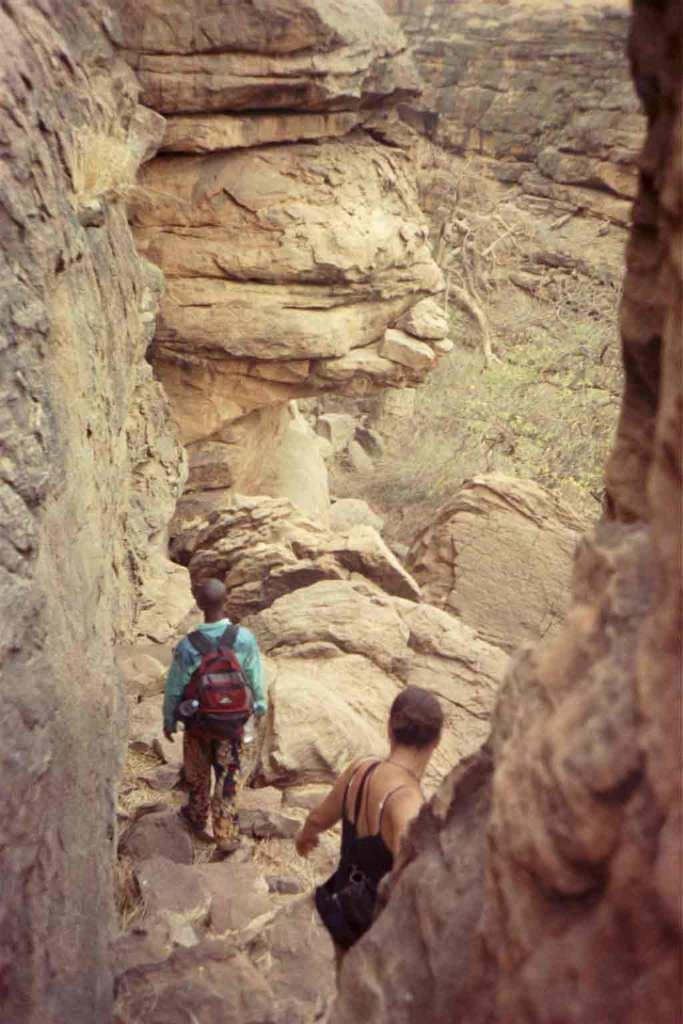How many people are in the image? There are people in the image, but the exact number is not specified. What is one of the people wearing? One of the people is wearing a bag. What can be seen in the background of the image? There are rock hills in the background of the image. What type of sail can be seen in the image? There is no sail present in the image. What color is the toy in the image? There is no toy present in the image. 